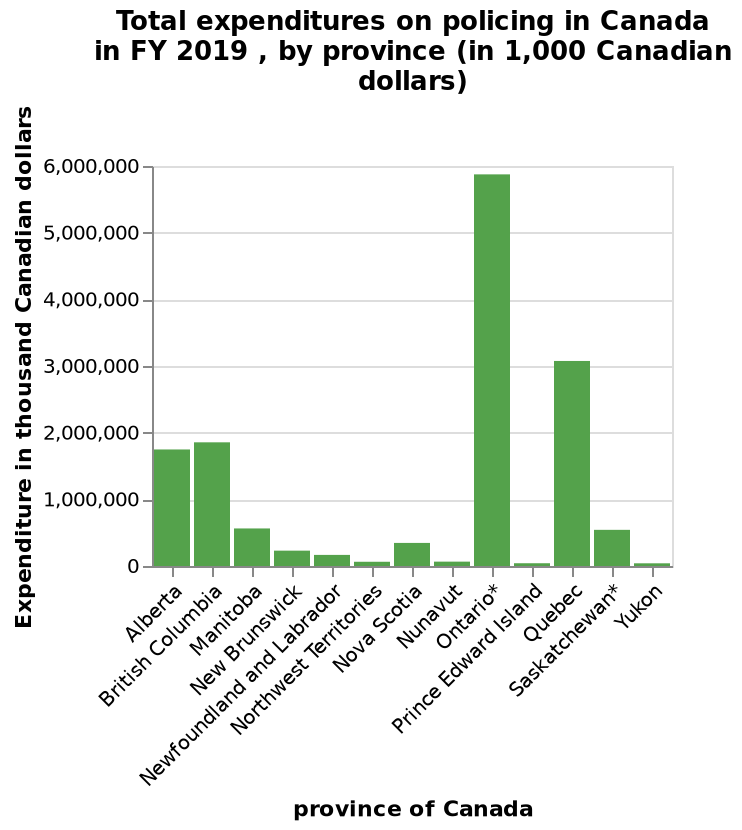<image>
Offer a thorough analysis of the image. Ontario has by far the highest spend on policing just shy of 6000. 2nd highest Quebec is only half at around 3000. Alberta and British columbia are the only other two provinces spending more than 1000 at just shy of 2000. The rest are all spending well below 1000. How much does Ontario spend on policing?  Ontario spends just shy of 6000. Which province had the second-highest total expenditure on policing in FY 2019? British Columbia had the second-highest total expenditure on policing in FY 2019. 